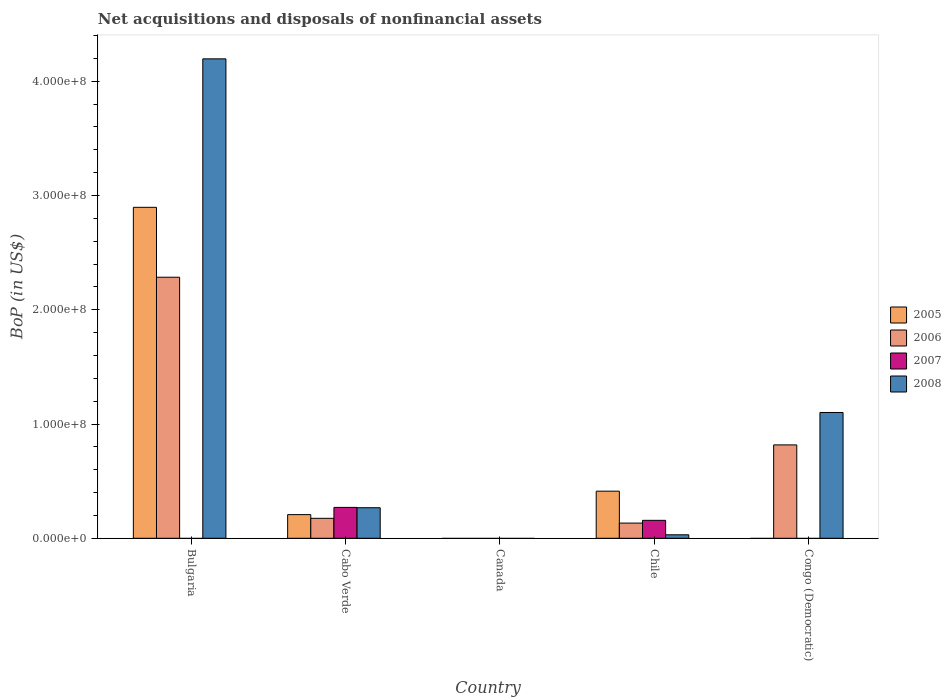How many different coloured bars are there?
Offer a terse response. 4. Are the number of bars per tick equal to the number of legend labels?
Offer a terse response. No. Are the number of bars on each tick of the X-axis equal?
Give a very brief answer. No. How many bars are there on the 4th tick from the left?
Make the answer very short. 4. How many bars are there on the 3rd tick from the right?
Provide a succinct answer. 0. What is the label of the 2nd group of bars from the left?
Ensure brevity in your answer.  Cabo Verde. Across all countries, what is the maximum Balance of Payments in 2008?
Your answer should be compact. 4.20e+08. Across all countries, what is the minimum Balance of Payments in 2008?
Ensure brevity in your answer.  0. In which country was the Balance of Payments in 2006 maximum?
Your answer should be compact. Bulgaria. What is the total Balance of Payments in 2005 in the graph?
Provide a succinct answer. 3.52e+08. What is the difference between the Balance of Payments in 2005 in Bulgaria and that in Cabo Verde?
Make the answer very short. 2.69e+08. What is the difference between the Balance of Payments in 2005 in Congo (Democratic) and the Balance of Payments in 2007 in Bulgaria?
Keep it short and to the point. 0. What is the average Balance of Payments in 2005 per country?
Offer a terse response. 7.03e+07. What is the difference between the Balance of Payments of/in 2006 and Balance of Payments of/in 2008 in Congo (Democratic)?
Offer a terse response. -2.84e+07. What is the ratio of the Balance of Payments in 2008 in Cabo Verde to that in Congo (Democratic)?
Your response must be concise. 0.24. Is the Balance of Payments in 2006 in Cabo Verde less than that in Congo (Democratic)?
Your answer should be compact. Yes. Is the difference between the Balance of Payments in 2006 in Chile and Congo (Democratic) greater than the difference between the Balance of Payments in 2008 in Chile and Congo (Democratic)?
Your response must be concise. Yes. What is the difference between the highest and the second highest Balance of Payments in 2008?
Keep it short and to the point. 8.34e+07. What is the difference between the highest and the lowest Balance of Payments in 2008?
Offer a very short reply. 4.20e+08. In how many countries, is the Balance of Payments in 2006 greater than the average Balance of Payments in 2006 taken over all countries?
Your response must be concise. 2. Is it the case that in every country, the sum of the Balance of Payments in 2006 and Balance of Payments in 2008 is greater than the Balance of Payments in 2007?
Provide a succinct answer. No. Are all the bars in the graph horizontal?
Offer a terse response. No. What is the difference between two consecutive major ticks on the Y-axis?
Offer a very short reply. 1.00e+08. Are the values on the major ticks of Y-axis written in scientific E-notation?
Ensure brevity in your answer.  Yes. Does the graph contain any zero values?
Give a very brief answer. Yes. Does the graph contain grids?
Ensure brevity in your answer.  No. How many legend labels are there?
Offer a terse response. 4. What is the title of the graph?
Make the answer very short. Net acquisitions and disposals of nonfinancial assets. Does "1971" appear as one of the legend labels in the graph?
Your response must be concise. No. What is the label or title of the X-axis?
Ensure brevity in your answer.  Country. What is the label or title of the Y-axis?
Your response must be concise. BoP (in US$). What is the BoP (in US$) of 2005 in Bulgaria?
Keep it short and to the point. 2.90e+08. What is the BoP (in US$) in 2006 in Bulgaria?
Provide a succinct answer. 2.28e+08. What is the BoP (in US$) of 2007 in Bulgaria?
Your answer should be very brief. 0. What is the BoP (in US$) of 2008 in Bulgaria?
Your response must be concise. 4.20e+08. What is the BoP (in US$) of 2005 in Cabo Verde?
Your answer should be compact. 2.07e+07. What is the BoP (in US$) in 2006 in Cabo Verde?
Offer a very short reply. 1.75e+07. What is the BoP (in US$) in 2007 in Cabo Verde?
Your answer should be very brief. 2.70e+07. What is the BoP (in US$) of 2008 in Cabo Verde?
Offer a very short reply. 2.67e+07. What is the BoP (in US$) of 2007 in Canada?
Keep it short and to the point. 0. What is the BoP (in US$) of 2005 in Chile?
Ensure brevity in your answer.  4.12e+07. What is the BoP (in US$) of 2006 in Chile?
Keep it short and to the point. 1.33e+07. What is the BoP (in US$) in 2007 in Chile?
Provide a succinct answer. 1.57e+07. What is the BoP (in US$) of 2008 in Chile?
Your answer should be compact. 3.06e+06. What is the BoP (in US$) in 2005 in Congo (Democratic)?
Give a very brief answer. 0. What is the BoP (in US$) in 2006 in Congo (Democratic)?
Provide a short and direct response. 8.17e+07. What is the BoP (in US$) of 2008 in Congo (Democratic)?
Your answer should be very brief. 1.10e+08. Across all countries, what is the maximum BoP (in US$) of 2005?
Provide a succinct answer. 2.90e+08. Across all countries, what is the maximum BoP (in US$) in 2006?
Keep it short and to the point. 2.28e+08. Across all countries, what is the maximum BoP (in US$) of 2007?
Make the answer very short. 2.70e+07. Across all countries, what is the maximum BoP (in US$) in 2008?
Give a very brief answer. 4.20e+08. Across all countries, what is the minimum BoP (in US$) of 2007?
Make the answer very short. 0. What is the total BoP (in US$) of 2005 in the graph?
Your answer should be very brief. 3.52e+08. What is the total BoP (in US$) in 2006 in the graph?
Provide a succinct answer. 3.41e+08. What is the total BoP (in US$) in 2007 in the graph?
Offer a terse response. 4.27e+07. What is the total BoP (in US$) in 2008 in the graph?
Keep it short and to the point. 5.60e+08. What is the difference between the BoP (in US$) of 2005 in Bulgaria and that in Cabo Verde?
Make the answer very short. 2.69e+08. What is the difference between the BoP (in US$) in 2006 in Bulgaria and that in Cabo Verde?
Provide a short and direct response. 2.11e+08. What is the difference between the BoP (in US$) in 2008 in Bulgaria and that in Cabo Verde?
Keep it short and to the point. 3.93e+08. What is the difference between the BoP (in US$) of 2005 in Bulgaria and that in Chile?
Provide a succinct answer. 2.48e+08. What is the difference between the BoP (in US$) in 2006 in Bulgaria and that in Chile?
Offer a terse response. 2.15e+08. What is the difference between the BoP (in US$) of 2008 in Bulgaria and that in Chile?
Offer a very short reply. 4.17e+08. What is the difference between the BoP (in US$) in 2006 in Bulgaria and that in Congo (Democratic)?
Offer a terse response. 1.47e+08. What is the difference between the BoP (in US$) of 2008 in Bulgaria and that in Congo (Democratic)?
Ensure brevity in your answer.  3.10e+08. What is the difference between the BoP (in US$) of 2005 in Cabo Verde and that in Chile?
Offer a very short reply. -2.05e+07. What is the difference between the BoP (in US$) in 2006 in Cabo Verde and that in Chile?
Your response must be concise. 4.17e+06. What is the difference between the BoP (in US$) in 2007 in Cabo Verde and that in Chile?
Offer a terse response. 1.13e+07. What is the difference between the BoP (in US$) in 2008 in Cabo Verde and that in Chile?
Keep it short and to the point. 2.37e+07. What is the difference between the BoP (in US$) of 2006 in Cabo Verde and that in Congo (Democratic)?
Provide a succinct answer. -6.43e+07. What is the difference between the BoP (in US$) in 2008 in Cabo Verde and that in Congo (Democratic)?
Keep it short and to the point. -8.34e+07. What is the difference between the BoP (in US$) in 2006 in Chile and that in Congo (Democratic)?
Your answer should be very brief. -6.84e+07. What is the difference between the BoP (in US$) in 2008 in Chile and that in Congo (Democratic)?
Offer a terse response. -1.07e+08. What is the difference between the BoP (in US$) of 2005 in Bulgaria and the BoP (in US$) of 2006 in Cabo Verde?
Your answer should be very brief. 2.72e+08. What is the difference between the BoP (in US$) in 2005 in Bulgaria and the BoP (in US$) in 2007 in Cabo Verde?
Offer a very short reply. 2.63e+08. What is the difference between the BoP (in US$) in 2005 in Bulgaria and the BoP (in US$) in 2008 in Cabo Verde?
Offer a very short reply. 2.63e+08. What is the difference between the BoP (in US$) in 2006 in Bulgaria and the BoP (in US$) in 2007 in Cabo Verde?
Make the answer very short. 2.01e+08. What is the difference between the BoP (in US$) of 2006 in Bulgaria and the BoP (in US$) of 2008 in Cabo Verde?
Ensure brevity in your answer.  2.02e+08. What is the difference between the BoP (in US$) of 2005 in Bulgaria and the BoP (in US$) of 2006 in Chile?
Provide a short and direct response. 2.76e+08. What is the difference between the BoP (in US$) of 2005 in Bulgaria and the BoP (in US$) of 2007 in Chile?
Your response must be concise. 2.74e+08. What is the difference between the BoP (in US$) in 2005 in Bulgaria and the BoP (in US$) in 2008 in Chile?
Keep it short and to the point. 2.87e+08. What is the difference between the BoP (in US$) in 2006 in Bulgaria and the BoP (in US$) in 2007 in Chile?
Your answer should be very brief. 2.13e+08. What is the difference between the BoP (in US$) in 2006 in Bulgaria and the BoP (in US$) in 2008 in Chile?
Your answer should be compact. 2.25e+08. What is the difference between the BoP (in US$) in 2005 in Bulgaria and the BoP (in US$) in 2006 in Congo (Democratic)?
Offer a terse response. 2.08e+08. What is the difference between the BoP (in US$) in 2005 in Bulgaria and the BoP (in US$) in 2008 in Congo (Democratic)?
Your answer should be very brief. 1.80e+08. What is the difference between the BoP (in US$) in 2006 in Bulgaria and the BoP (in US$) in 2008 in Congo (Democratic)?
Make the answer very short. 1.18e+08. What is the difference between the BoP (in US$) in 2005 in Cabo Verde and the BoP (in US$) in 2006 in Chile?
Make the answer very short. 7.41e+06. What is the difference between the BoP (in US$) of 2005 in Cabo Verde and the BoP (in US$) of 2007 in Chile?
Your answer should be compact. 5.00e+06. What is the difference between the BoP (in US$) in 2005 in Cabo Verde and the BoP (in US$) in 2008 in Chile?
Keep it short and to the point. 1.77e+07. What is the difference between the BoP (in US$) of 2006 in Cabo Verde and the BoP (in US$) of 2007 in Chile?
Your response must be concise. 1.76e+06. What is the difference between the BoP (in US$) of 2006 in Cabo Verde and the BoP (in US$) of 2008 in Chile?
Offer a very short reply. 1.44e+07. What is the difference between the BoP (in US$) of 2007 in Cabo Verde and the BoP (in US$) of 2008 in Chile?
Make the answer very short. 2.40e+07. What is the difference between the BoP (in US$) of 2005 in Cabo Verde and the BoP (in US$) of 2006 in Congo (Democratic)?
Provide a short and direct response. -6.10e+07. What is the difference between the BoP (in US$) in 2005 in Cabo Verde and the BoP (in US$) in 2008 in Congo (Democratic)?
Ensure brevity in your answer.  -8.94e+07. What is the difference between the BoP (in US$) of 2006 in Cabo Verde and the BoP (in US$) of 2008 in Congo (Democratic)?
Your answer should be very brief. -9.26e+07. What is the difference between the BoP (in US$) in 2007 in Cabo Verde and the BoP (in US$) in 2008 in Congo (Democratic)?
Provide a short and direct response. -8.31e+07. What is the difference between the BoP (in US$) in 2005 in Chile and the BoP (in US$) in 2006 in Congo (Democratic)?
Make the answer very short. -4.05e+07. What is the difference between the BoP (in US$) of 2005 in Chile and the BoP (in US$) of 2008 in Congo (Democratic)?
Your answer should be very brief. -6.89e+07. What is the difference between the BoP (in US$) in 2006 in Chile and the BoP (in US$) in 2008 in Congo (Democratic)?
Your answer should be very brief. -9.68e+07. What is the difference between the BoP (in US$) in 2007 in Chile and the BoP (in US$) in 2008 in Congo (Democratic)?
Keep it short and to the point. -9.44e+07. What is the average BoP (in US$) in 2005 per country?
Make the answer very short. 7.03e+07. What is the average BoP (in US$) in 2006 per country?
Offer a very short reply. 6.82e+07. What is the average BoP (in US$) of 2007 per country?
Offer a very short reply. 8.55e+06. What is the average BoP (in US$) in 2008 per country?
Your answer should be very brief. 1.12e+08. What is the difference between the BoP (in US$) in 2005 and BoP (in US$) in 2006 in Bulgaria?
Provide a short and direct response. 6.12e+07. What is the difference between the BoP (in US$) of 2005 and BoP (in US$) of 2008 in Bulgaria?
Give a very brief answer. -1.30e+08. What is the difference between the BoP (in US$) of 2006 and BoP (in US$) of 2008 in Bulgaria?
Ensure brevity in your answer.  -1.91e+08. What is the difference between the BoP (in US$) in 2005 and BoP (in US$) in 2006 in Cabo Verde?
Provide a short and direct response. 3.24e+06. What is the difference between the BoP (in US$) in 2005 and BoP (in US$) in 2007 in Cabo Verde?
Keep it short and to the point. -6.32e+06. What is the difference between the BoP (in US$) in 2005 and BoP (in US$) in 2008 in Cabo Verde?
Your answer should be very brief. -6.04e+06. What is the difference between the BoP (in US$) of 2006 and BoP (in US$) of 2007 in Cabo Verde?
Your answer should be very brief. -9.56e+06. What is the difference between the BoP (in US$) of 2006 and BoP (in US$) of 2008 in Cabo Verde?
Keep it short and to the point. -9.28e+06. What is the difference between the BoP (in US$) of 2007 and BoP (in US$) of 2008 in Cabo Verde?
Offer a terse response. 2.85e+05. What is the difference between the BoP (in US$) in 2005 and BoP (in US$) in 2006 in Chile?
Provide a succinct answer. 2.79e+07. What is the difference between the BoP (in US$) of 2005 and BoP (in US$) of 2007 in Chile?
Offer a terse response. 2.55e+07. What is the difference between the BoP (in US$) in 2005 and BoP (in US$) in 2008 in Chile?
Offer a very short reply. 3.82e+07. What is the difference between the BoP (in US$) of 2006 and BoP (in US$) of 2007 in Chile?
Make the answer very short. -2.41e+06. What is the difference between the BoP (in US$) in 2006 and BoP (in US$) in 2008 in Chile?
Keep it short and to the point. 1.02e+07. What is the difference between the BoP (in US$) of 2007 and BoP (in US$) of 2008 in Chile?
Your answer should be very brief. 1.27e+07. What is the difference between the BoP (in US$) in 2006 and BoP (in US$) in 2008 in Congo (Democratic)?
Your answer should be very brief. -2.84e+07. What is the ratio of the BoP (in US$) of 2005 in Bulgaria to that in Cabo Verde?
Your answer should be very brief. 13.99. What is the ratio of the BoP (in US$) of 2006 in Bulgaria to that in Cabo Verde?
Provide a short and direct response. 13.08. What is the ratio of the BoP (in US$) in 2008 in Bulgaria to that in Cabo Verde?
Keep it short and to the point. 15.69. What is the ratio of the BoP (in US$) in 2005 in Bulgaria to that in Chile?
Offer a terse response. 7.02. What is the ratio of the BoP (in US$) of 2006 in Bulgaria to that in Chile?
Offer a very short reply. 17.18. What is the ratio of the BoP (in US$) in 2008 in Bulgaria to that in Chile?
Provide a short and direct response. 137.31. What is the ratio of the BoP (in US$) in 2006 in Bulgaria to that in Congo (Democratic)?
Your answer should be very brief. 2.8. What is the ratio of the BoP (in US$) of 2008 in Bulgaria to that in Congo (Democratic)?
Offer a terse response. 3.81. What is the ratio of the BoP (in US$) in 2005 in Cabo Verde to that in Chile?
Offer a terse response. 0.5. What is the ratio of the BoP (in US$) in 2006 in Cabo Verde to that in Chile?
Provide a succinct answer. 1.31. What is the ratio of the BoP (in US$) in 2007 in Cabo Verde to that in Chile?
Your answer should be compact. 1.72. What is the ratio of the BoP (in US$) of 2008 in Cabo Verde to that in Chile?
Your answer should be compact. 8.75. What is the ratio of the BoP (in US$) of 2006 in Cabo Verde to that in Congo (Democratic)?
Make the answer very short. 0.21. What is the ratio of the BoP (in US$) of 2008 in Cabo Verde to that in Congo (Democratic)?
Offer a terse response. 0.24. What is the ratio of the BoP (in US$) in 2006 in Chile to that in Congo (Democratic)?
Give a very brief answer. 0.16. What is the ratio of the BoP (in US$) in 2008 in Chile to that in Congo (Democratic)?
Your answer should be very brief. 0.03. What is the difference between the highest and the second highest BoP (in US$) in 2005?
Your answer should be very brief. 2.48e+08. What is the difference between the highest and the second highest BoP (in US$) of 2006?
Your response must be concise. 1.47e+08. What is the difference between the highest and the second highest BoP (in US$) in 2008?
Offer a terse response. 3.10e+08. What is the difference between the highest and the lowest BoP (in US$) of 2005?
Your answer should be compact. 2.90e+08. What is the difference between the highest and the lowest BoP (in US$) in 2006?
Keep it short and to the point. 2.28e+08. What is the difference between the highest and the lowest BoP (in US$) of 2007?
Offer a terse response. 2.70e+07. What is the difference between the highest and the lowest BoP (in US$) of 2008?
Give a very brief answer. 4.20e+08. 